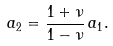<formula> <loc_0><loc_0><loc_500><loc_500>a _ { 2 } = \frac { 1 + \nu } { 1 - \nu } \, a _ { 1 } .</formula> 